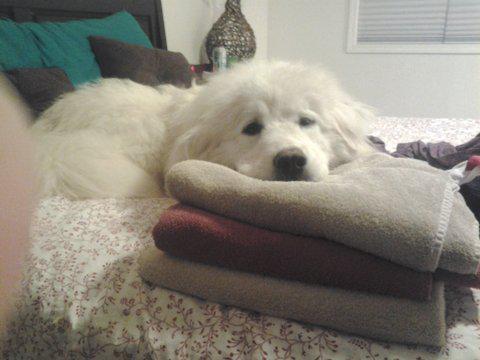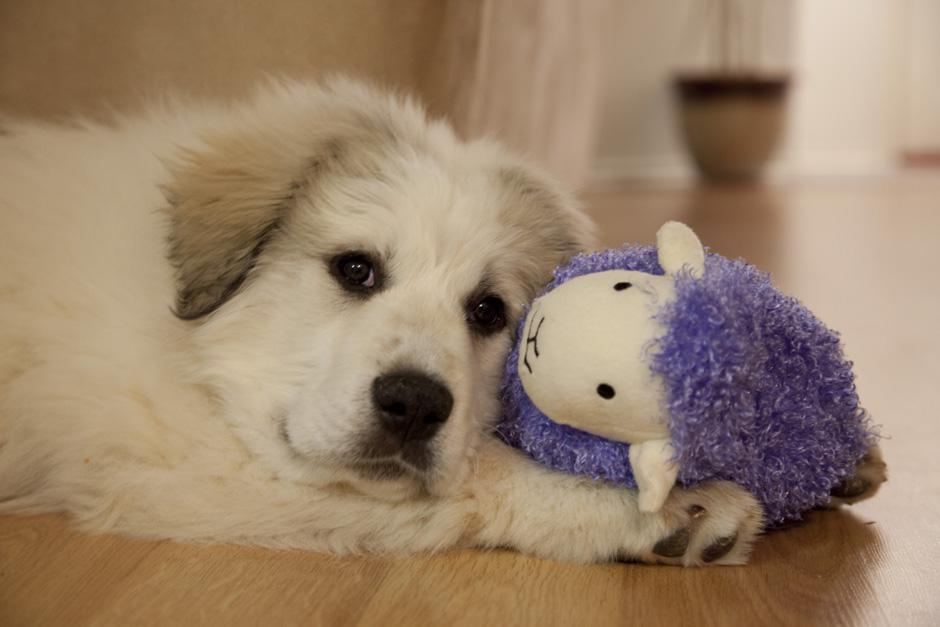The first image is the image on the left, the second image is the image on the right. Examine the images to the left and right. Is the description "The dog in only one of the images has its eyes open." accurate? Answer yes or no. No. The first image is the image on the left, the second image is the image on the right. Given the left and right images, does the statement "A bright red plush item is next to the head of the dog in one image." hold true? Answer yes or no. No. 